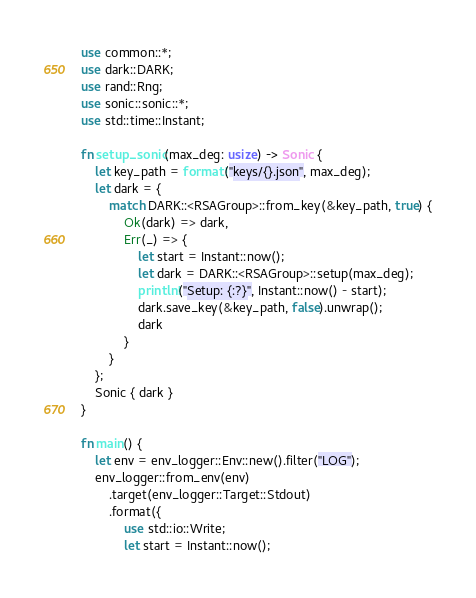Convert code to text. <code><loc_0><loc_0><loc_500><loc_500><_Rust_>use common::*;
use dark::DARK;
use rand::Rng;
use sonic::sonic::*;
use std::time::Instant;

fn setup_sonic(max_deg: usize) -> Sonic {
    let key_path = format!("keys/{}.json", max_deg);
    let dark = {
        match DARK::<RSAGroup>::from_key(&key_path, true) {
            Ok(dark) => dark,
            Err(_) => {
                let start = Instant::now();
                let dark = DARK::<RSAGroup>::setup(max_deg);
                println!("Setup: {:?}", Instant::now() - start);
                dark.save_key(&key_path, false).unwrap();
                dark
            }
        }
    };
    Sonic { dark }
}

fn main() {
    let env = env_logger::Env::new().filter("LOG");
    env_logger::from_env(env)
        .target(env_logger::Target::Stdout)
        .format({
            use std::io::Write;
            let start = Instant::now();</code> 